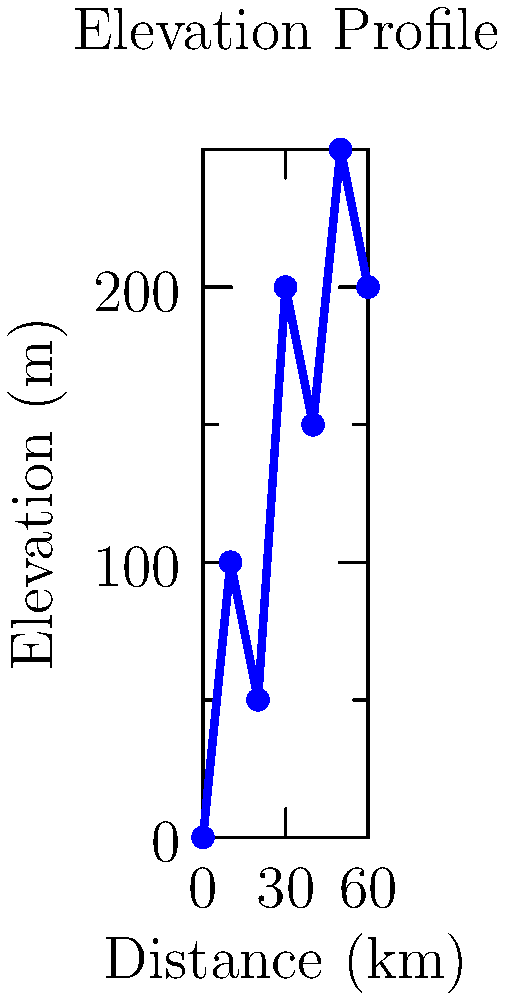Based on the elevation profile shown, estimate the total calories burned during a 60 km ride if the cyclist maintains an average speed of 25 km/h. Assume the cyclist weighs 70 kg and burns an average of 8 calories per kilometer on flat terrain, with an additional 0.1 calories per meter of elevation gain. To estimate the total calories burned, we need to consider both the distance and the elevation gain:

1. Calculate base calories burned for the distance:
   - Distance = 60 km
   - Base calorie burn = 60 km × 8 calories/km = 480 calories

2. Calculate total elevation gain:
   - Starting elevation: 0 m
   - Highest point: 250 m
   - Total elevation gain: (100 + 150 + 100) m = 350 m

3. Calculate additional calories burned due to elevation gain:
   - Additional calories = 350 m × 0.1 calories/m = 35 calories

4. Sum up total calories burned:
   - Total calories = Base calories + Additional calories
   - Total calories = 480 + 35 = 515 calories

5. Adjust for speed:
   - The average speed of 25 km/h is relatively high for a recreational cyclist, especially considering the elevation profile.
   - We can estimate a 10% increase in calorie burn due to the higher intensity.
   - Final calorie estimate = 515 × 1.1 ≈ 567 calories
Answer: Approximately 567 calories 